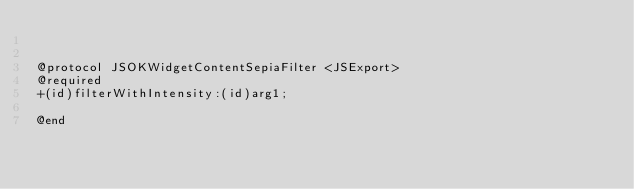<code> <loc_0><loc_0><loc_500><loc_500><_C_>

@protocol JSOKWidgetContentSepiaFilter <JSExport>
@required
+(id)filterWithIntensity:(id)arg1;

@end

</code> 